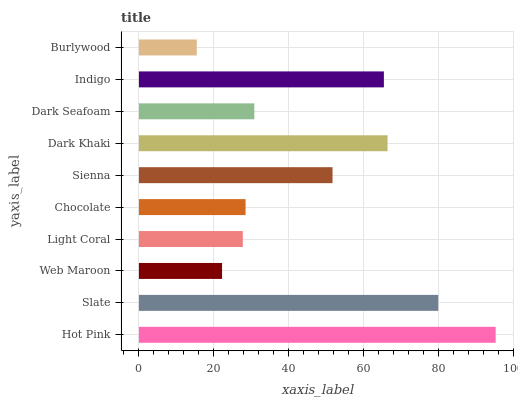Is Burlywood the minimum?
Answer yes or no. Yes. Is Hot Pink the maximum?
Answer yes or no. Yes. Is Slate the minimum?
Answer yes or no. No. Is Slate the maximum?
Answer yes or no. No. Is Hot Pink greater than Slate?
Answer yes or no. Yes. Is Slate less than Hot Pink?
Answer yes or no. Yes. Is Slate greater than Hot Pink?
Answer yes or no. No. Is Hot Pink less than Slate?
Answer yes or no. No. Is Sienna the high median?
Answer yes or no. Yes. Is Dark Seafoam the low median?
Answer yes or no. Yes. Is Chocolate the high median?
Answer yes or no. No. Is Chocolate the low median?
Answer yes or no. No. 